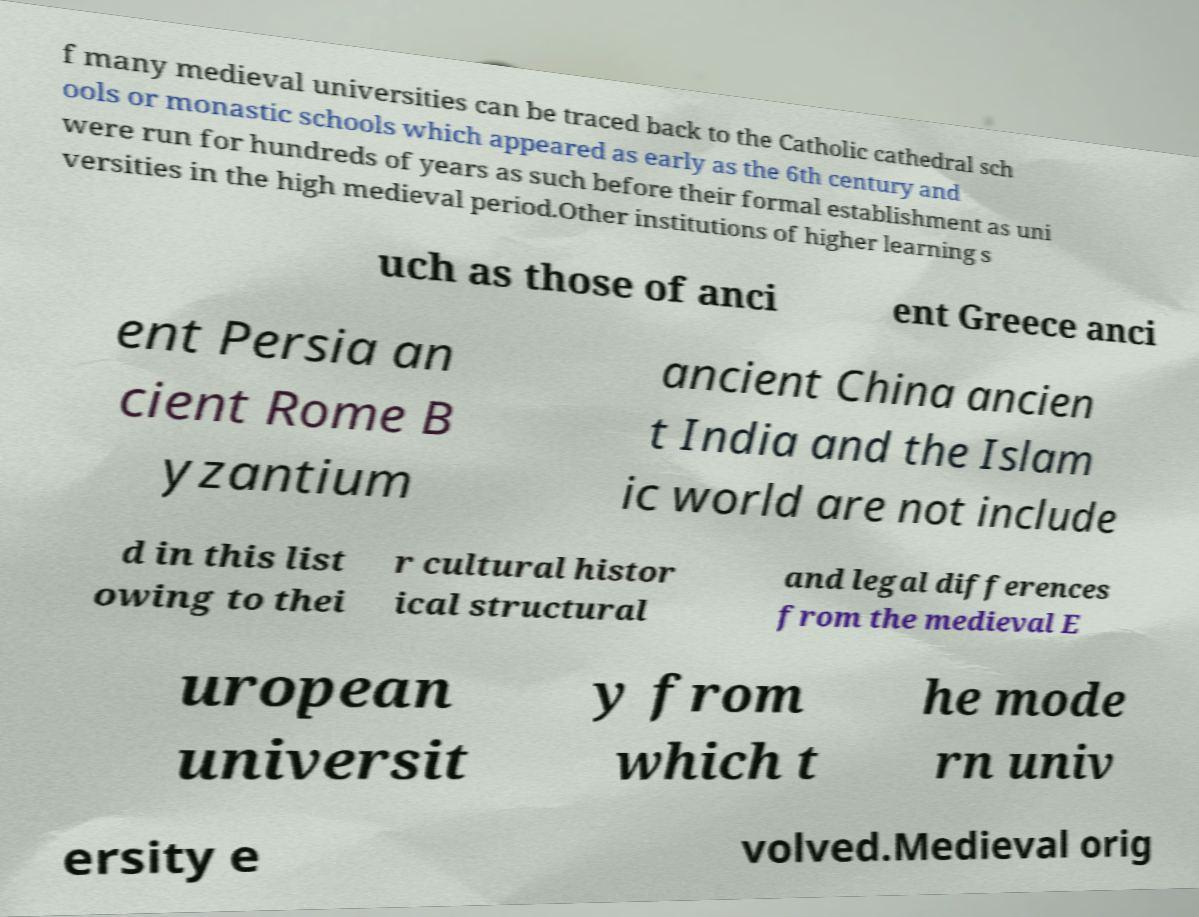Could you extract and type out the text from this image? f many medieval universities can be traced back to the Catholic cathedral sch ools or monastic schools which appeared as early as the 6th century and were run for hundreds of years as such before their formal establishment as uni versities in the high medieval period.Other institutions of higher learning s uch as those of anci ent Greece anci ent Persia an cient Rome B yzantium ancient China ancien t India and the Islam ic world are not include d in this list owing to thei r cultural histor ical structural and legal differences from the medieval E uropean universit y from which t he mode rn univ ersity e volved.Medieval orig 